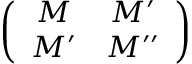<formula> <loc_0><loc_0><loc_500><loc_500>\left ( \begin{array} { c c } { M } & { { M ^ { \prime } } } \\ { { M ^ { \prime } } } & { { M ^ { \prime \prime } } } \end{array} \right )</formula> 